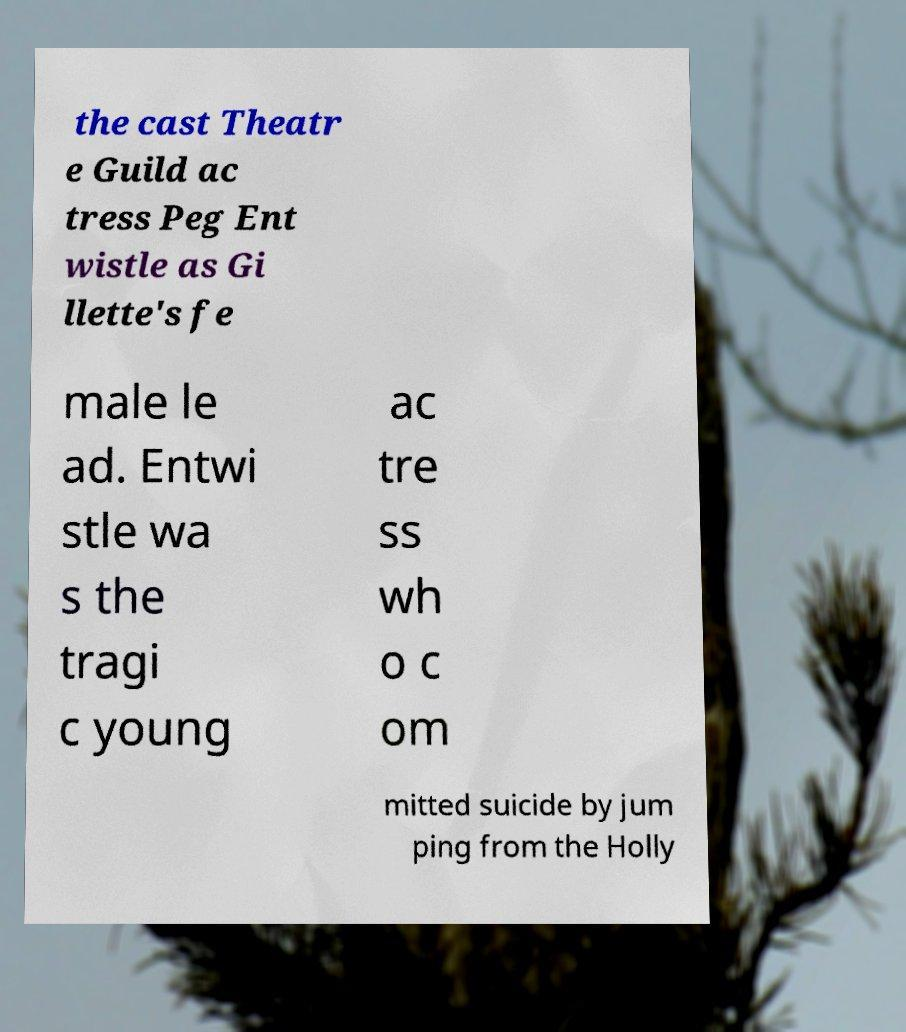Could you extract and type out the text from this image? the cast Theatr e Guild ac tress Peg Ent wistle as Gi llette's fe male le ad. Entwi stle wa s the tragi c young ac tre ss wh o c om mitted suicide by jum ping from the Holly 